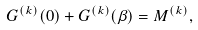<formula> <loc_0><loc_0><loc_500><loc_500>G ^ { ( k ) } ( 0 ) + G ^ { ( k ) } ( \beta ) = M ^ { ( k ) } ,</formula> 